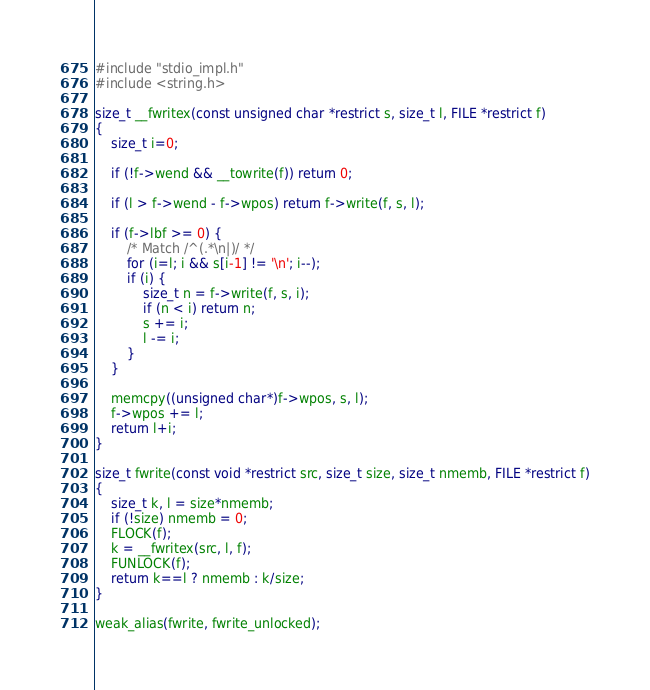<code> <loc_0><loc_0><loc_500><loc_500><_C_>#include "stdio_impl.h"
#include <string.h>

size_t __fwritex(const unsigned char *restrict s, size_t l, FILE *restrict f)
{
	size_t i=0;

	if (!f->wend && __towrite(f)) return 0;

	if (l > f->wend - f->wpos) return f->write(f, s, l);

	if (f->lbf >= 0) {
		/* Match /^(.*\n|)/ */
		for (i=l; i && s[i-1] != '\n'; i--);
		if (i) {
			size_t n = f->write(f, s, i);
			if (n < i) return n;
			s += i;
			l -= i;
		}
	}

	memcpy((unsigned char*)f->wpos, s, l);
	f->wpos += l;
	return l+i;
}

size_t fwrite(const void *restrict src, size_t size, size_t nmemb, FILE *restrict f)
{
	size_t k, l = size*nmemb;
	if (!size) nmemb = 0;
	FLOCK(f);
	k = __fwritex(src, l, f);
	FUNLOCK(f);
	return k==l ? nmemb : k/size;
}

weak_alias(fwrite, fwrite_unlocked);
</code> 